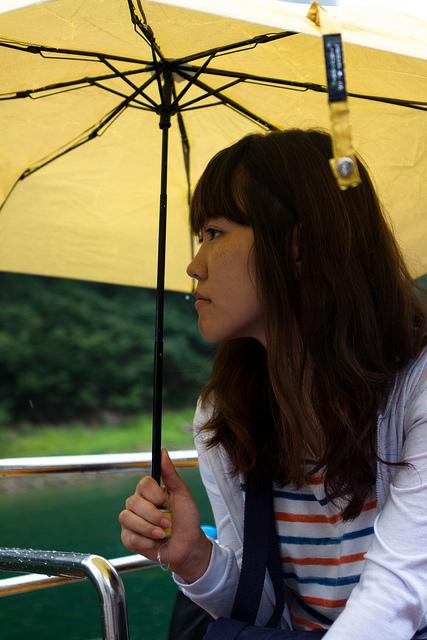What does this person use the umbrella for?

Choices:
A) snow
B) hail
C) sun
D) rain rain 